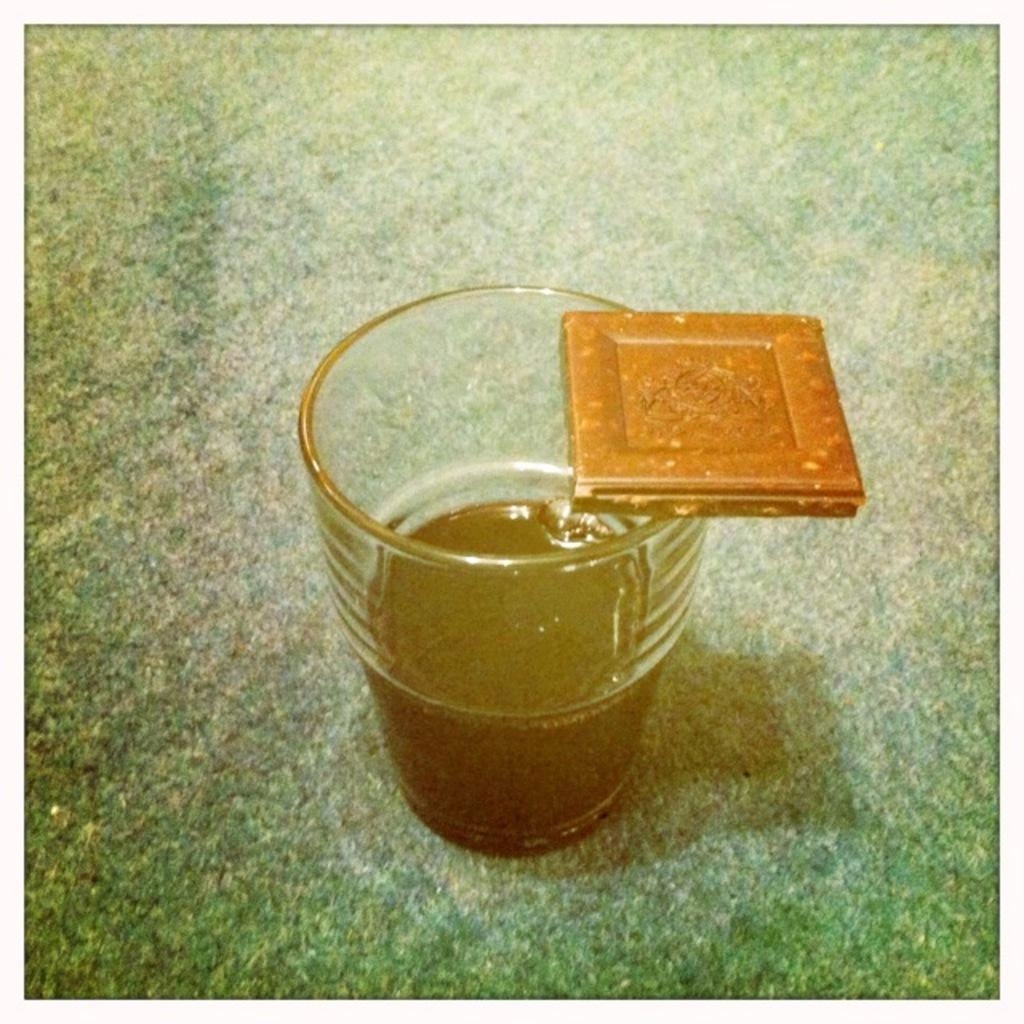What is the main object in the center of the image? There is a glass in the center of the image. How many rabbits can be seen jumping over the glass in the image? There are no rabbits present in the image, and therefore no such activity can be observed. 